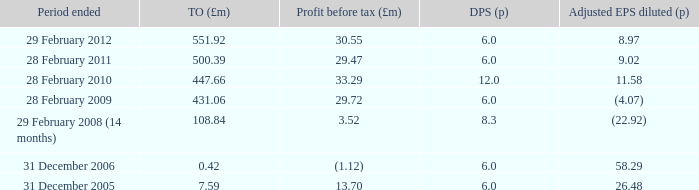How many items appear in the dividend per share when the turnover is 0.42? 1.0. 